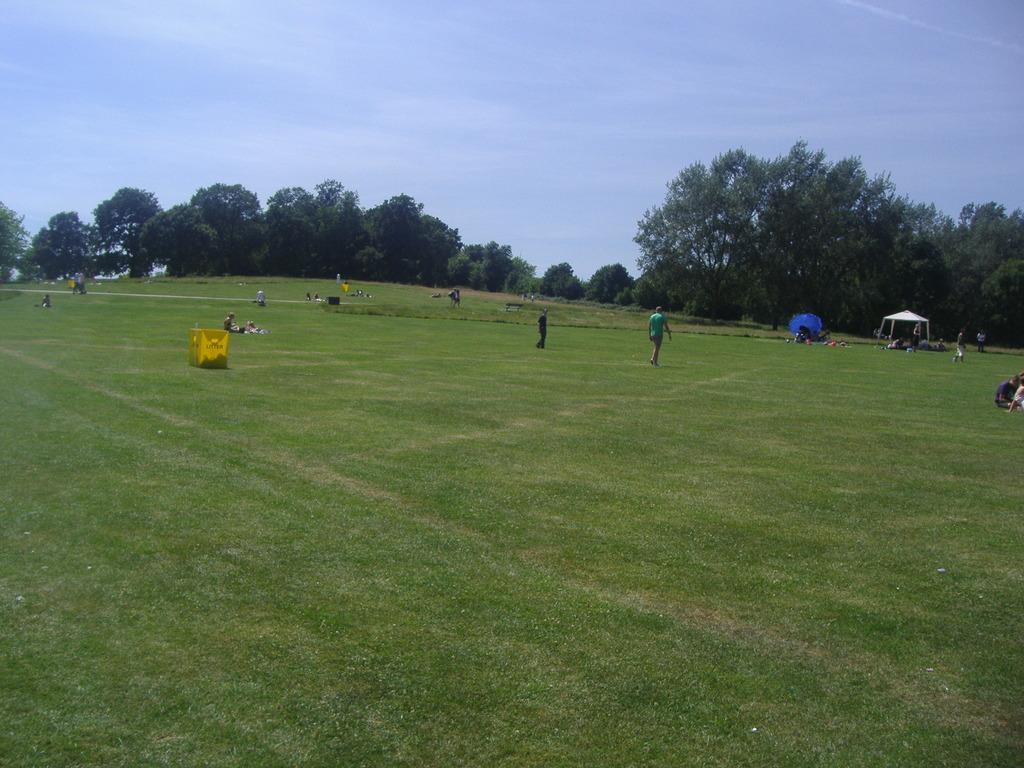Can you describe this image briefly? In this image, we can see people wearing clothes. There are some trees in the middle of the image. At the top of the image, we can see the sky. 